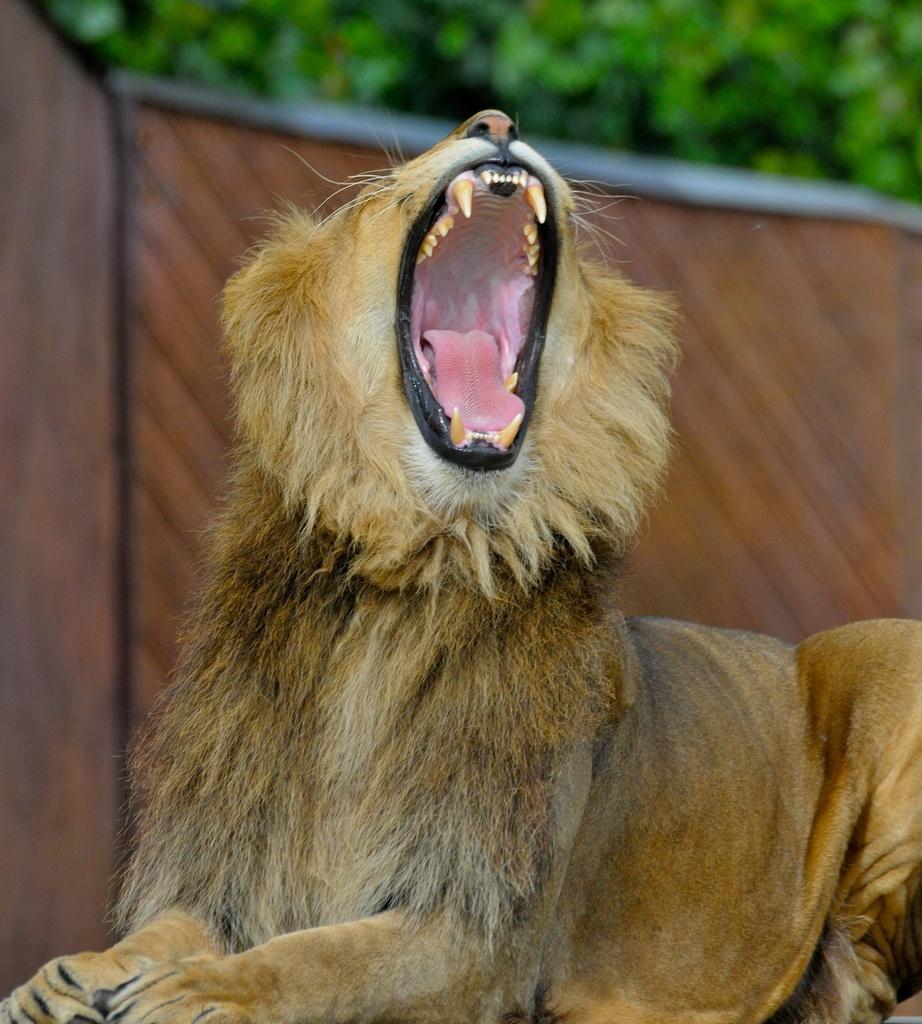Please provide a concise description of this image. Here in this picture we can see a lion yawning, as we can see its mouth wide opened and behind it we can see a wall present and we can see trees present all over there. 